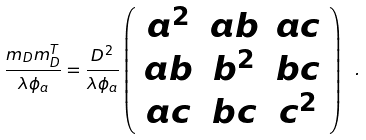Convert formula to latex. <formula><loc_0><loc_0><loc_500><loc_500>\frac { m _ { D } m _ { D } ^ { T } } { \lambda \phi _ { a } } = \frac { D ^ { 2 } } { \lambda \phi _ { a } } \left ( \begin{array} { c c c } a ^ { 2 } & a b & a c \\ a b & b ^ { 2 } & b c \\ a c & b c & c ^ { 2 } \end{array} \right ) \ .</formula> 